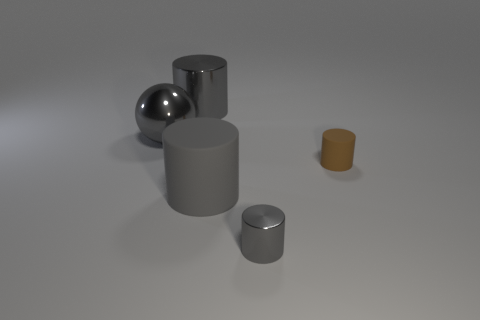Subtract all cyan blocks. How many gray cylinders are left? 3 Add 1 tiny cylinders. How many objects exist? 6 Subtract all cylinders. How many objects are left? 1 Add 2 green rubber objects. How many green rubber objects exist? 2 Subtract 0 brown blocks. How many objects are left? 5 Subtract all large cyan rubber cubes. Subtract all small objects. How many objects are left? 3 Add 1 tiny gray metal cylinders. How many tiny gray metal cylinders are left? 2 